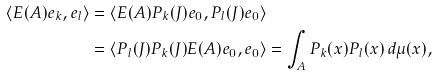Convert formula to latex. <formula><loc_0><loc_0><loc_500><loc_500>\langle E ( A ) e _ { k } , e _ { l } \rangle & = \langle E ( A ) P _ { k } ( J ) e _ { 0 } , P _ { l } ( J ) e _ { 0 } \rangle \\ & = \langle P _ { l } ( J ) P _ { k } ( J ) E ( A ) e _ { 0 } , e _ { 0 } \rangle = \int _ { A } P _ { k } ( x ) P _ { l } ( x ) \, d \mu ( x ) ,</formula> 